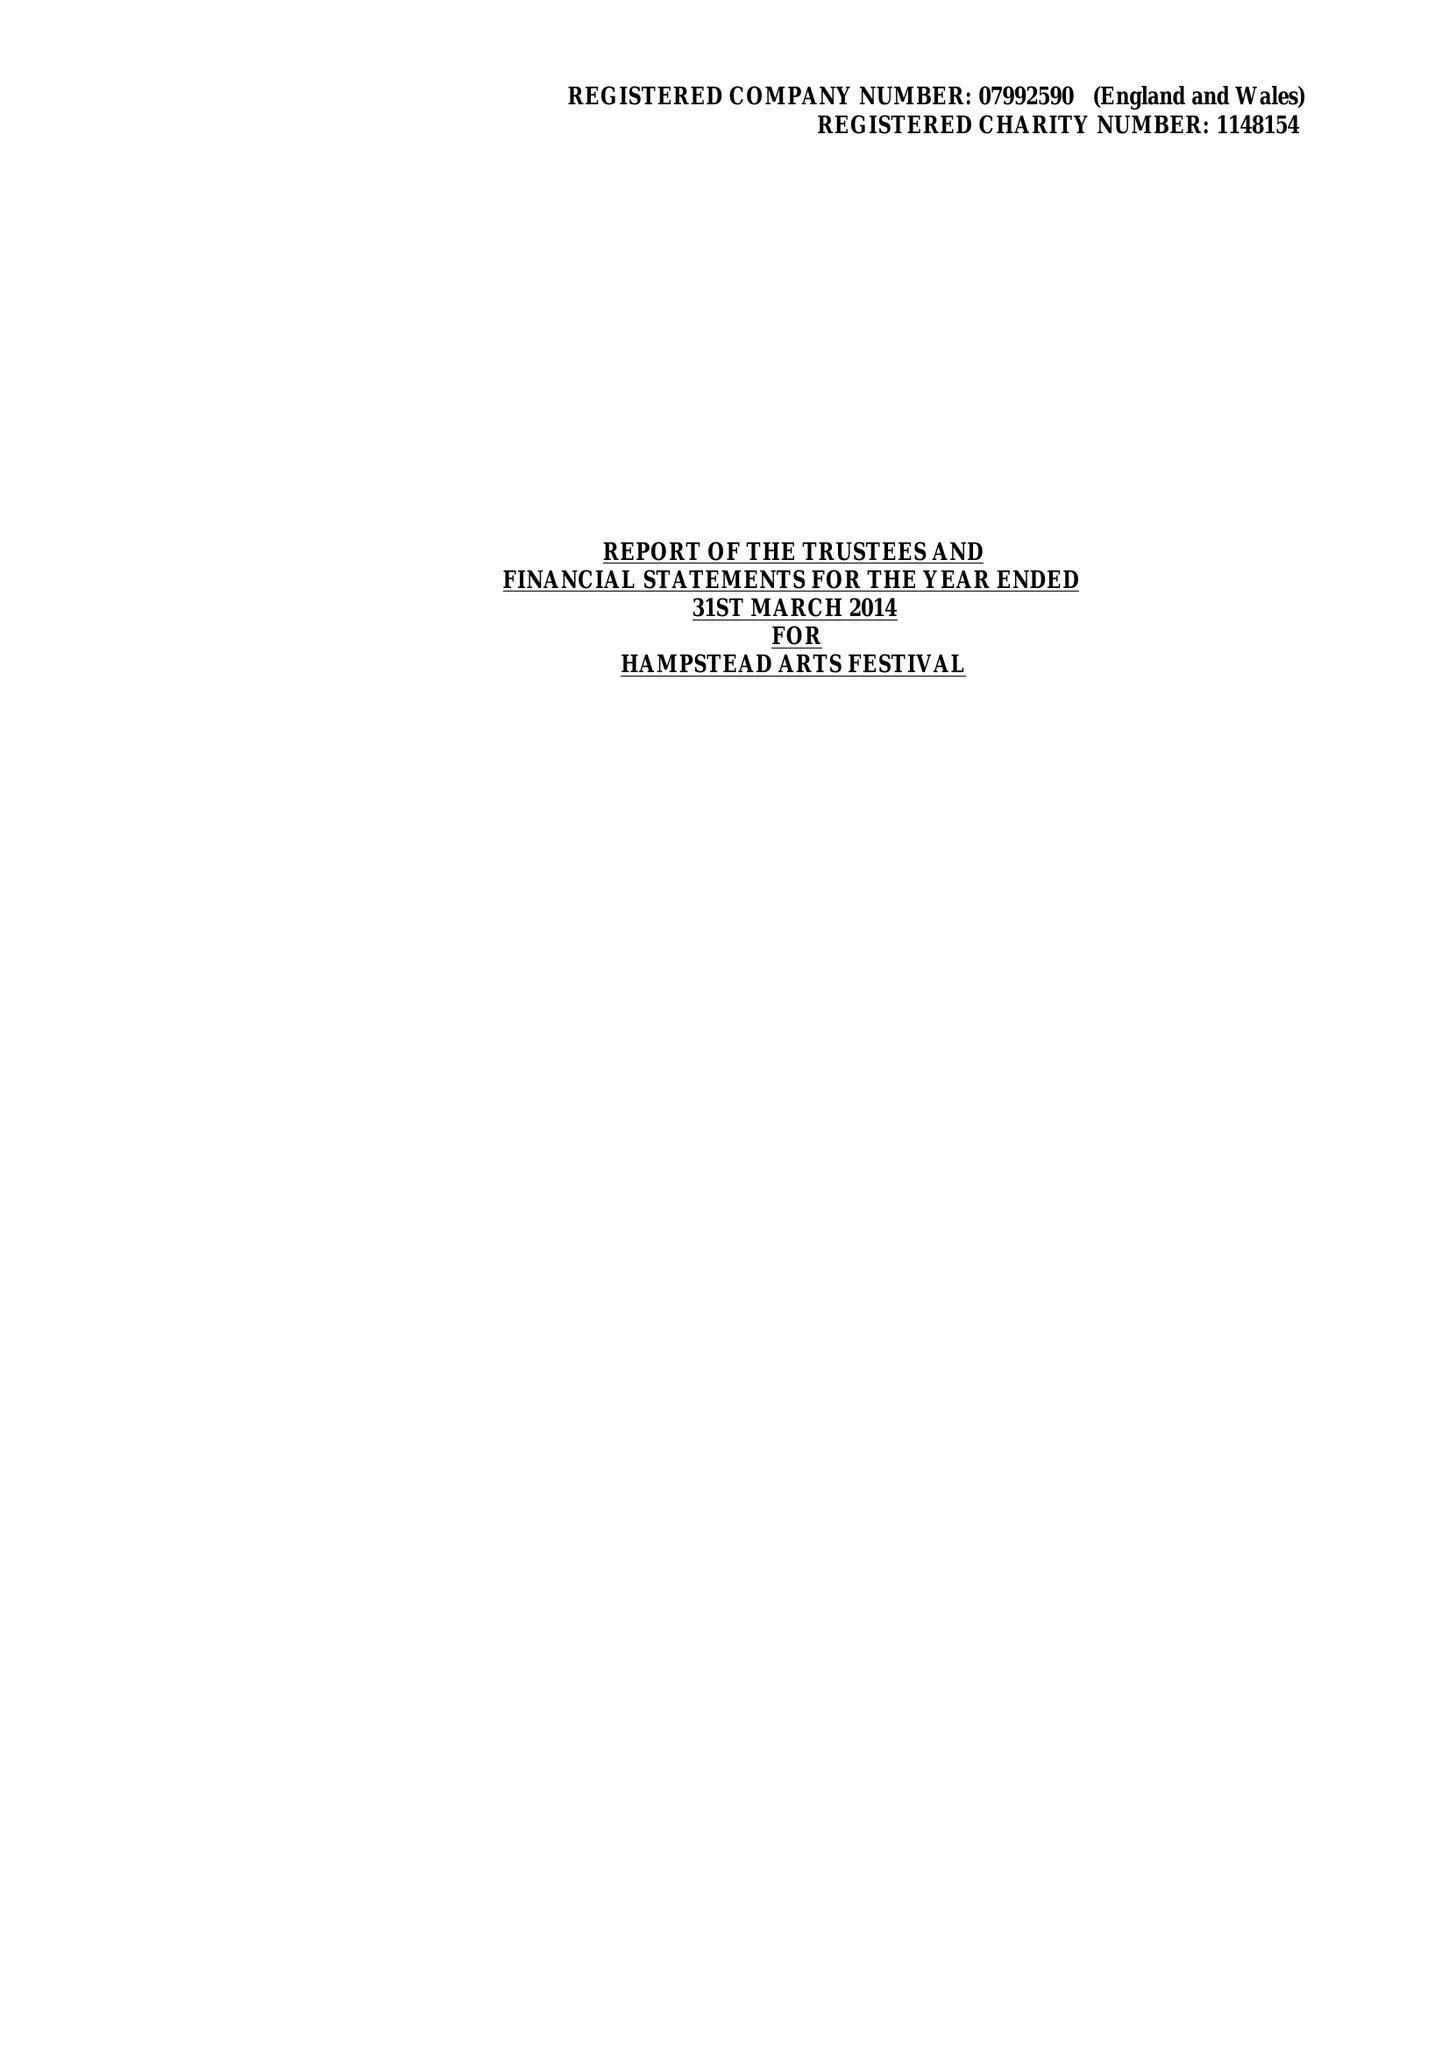What is the value for the spending_annually_in_british_pounds?
Answer the question using a single word or phrase. 34815.00 